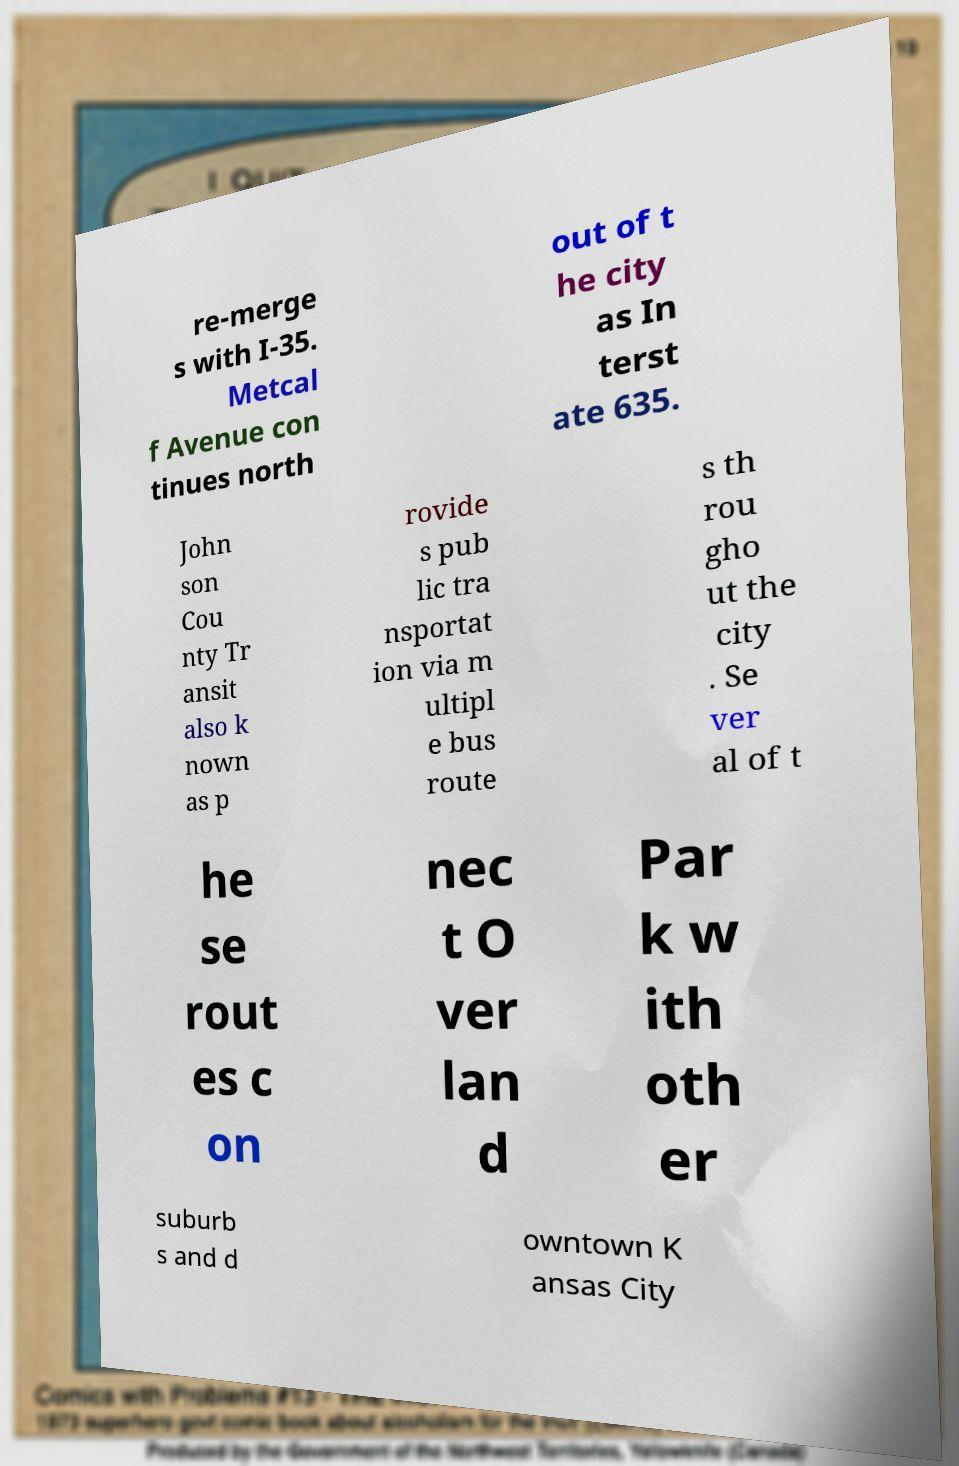Could you assist in decoding the text presented in this image and type it out clearly? re-merge s with I-35. Metcal f Avenue con tinues north out of t he city as In terst ate 635. John son Cou nty Tr ansit also k nown as p rovide s pub lic tra nsportat ion via m ultipl e bus route s th rou gho ut the city . Se ver al of t he se rout es c on nec t O ver lan d Par k w ith oth er suburb s and d owntown K ansas City 